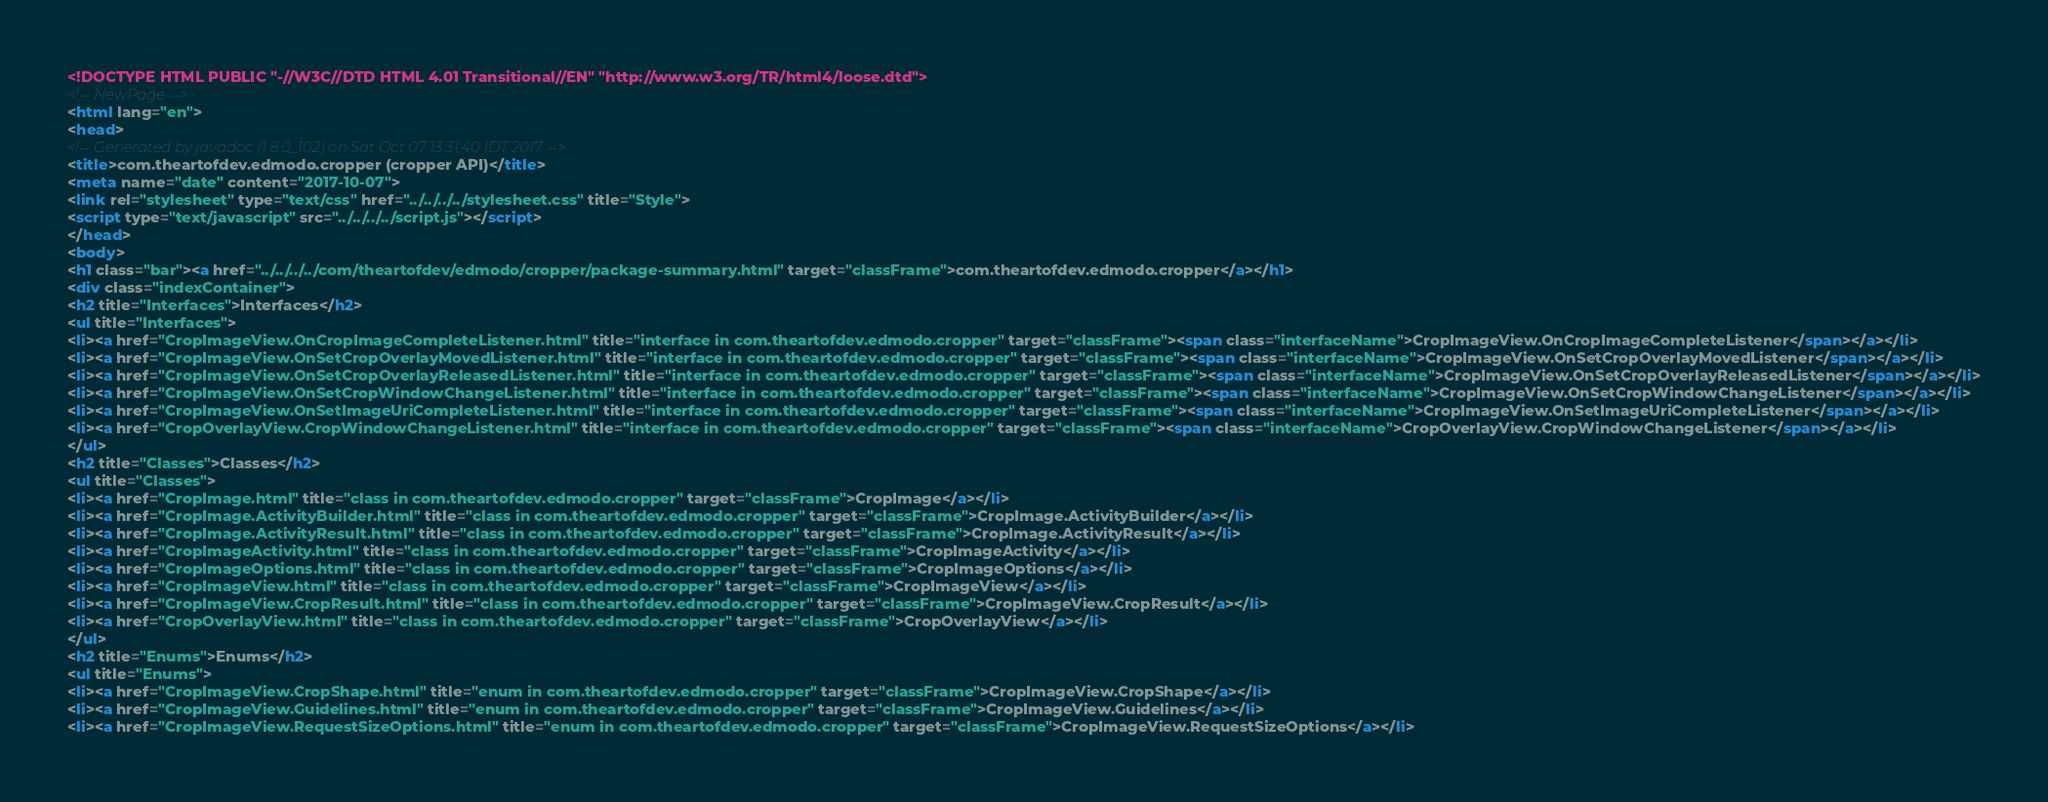<code> <loc_0><loc_0><loc_500><loc_500><_HTML_><!DOCTYPE HTML PUBLIC "-//W3C//DTD HTML 4.01 Transitional//EN" "http://www.w3.org/TR/html4/loose.dtd">
<!-- NewPage -->
<html lang="en">
<head>
<!-- Generated by javadoc (1.8.0_102) on Sat Oct 07 13:31:40 IDT 2017 -->
<title>com.theartofdev.edmodo.cropper (cropper API)</title>
<meta name="date" content="2017-10-07">
<link rel="stylesheet" type="text/css" href="../../../../stylesheet.css" title="Style">
<script type="text/javascript" src="../../../../script.js"></script>
</head>
<body>
<h1 class="bar"><a href="../../../../com/theartofdev/edmodo/cropper/package-summary.html" target="classFrame">com.theartofdev.edmodo.cropper</a></h1>
<div class="indexContainer">
<h2 title="Interfaces">Interfaces</h2>
<ul title="Interfaces">
<li><a href="CropImageView.OnCropImageCompleteListener.html" title="interface in com.theartofdev.edmodo.cropper" target="classFrame"><span class="interfaceName">CropImageView.OnCropImageCompleteListener</span></a></li>
<li><a href="CropImageView.OnSetCropOverlayMovedListener.html" title="interface in com.theartofdev.edmodo.cropper" target="classFrame"><span class="interfaceName">CropImageView.OnSetCropOverlayMovedListener</span></a></li>
<li><a href="CropImageView.OnSetCropOverlayReleasedListener.html" title="interface in com.theartofdev.edmodo.cropper" target="classFrame"><span class="interfaceName">CropImageView.OnSetCropOverlayReleasedListener</span></a></li>
<li><a href="CropImageView.OnSetCropWindowChangeListener.html" title="interface in com.theartofdev.edmodo.cropper" target="classFrame"><span class="interfaceName">CropImageView.OnSetCropWindowChangeListener</span></a></li>
<li><a href="CropImageView.OnSetImageUriCompleteListener.html" title="interface in com.theartofdev.edmodo.cropper" target="classFrame"><span class="interfaceName">CropImageView.OnSetImageUriCompleteListener</span></a></li>
<li><a href="CropOverlayView.CropWindowChangeListener.html" title="interface in com.theartofdev.edmodo.cropper" target="classFrame"><span class="interfaceName">CropOverlayView.CropWindowChangeListener</span></a></li>
</ul>
<h2 title="Classes">Classes</h2>
<ul title="Classes">
<li><a href="CropImage.html" title="class in com.theartofdev.edmodo.cropper" target="classFrame">CropImage</a></li>
<li><a href="CropImage.ActivityBuilder.html" title="class in com.theartofdev.edmodo.cropper" target="classFrame">CropImage.ActivityBuilder</a></li>
<li><a href="CropImage.ActivityResult.html" title="class in com.theartofdev.edmodo.cropper" target="classFrame">CropImage.ActivityResult</a></li>
<li><a href="CropImageActivity.html" title="class in com.theartofdev.edmodo.cropper" target="classFrame">CropImageActivity</a></li>
<li><a href="CropImageOptions.html" title="class in com.theartofdev.edmodo.cropper" target="classFrame">CropImageOptions</a></li>
<li><a href="CropImageView.html" title="class in com.theartofdev.edmodo.cropper" target="classFrame">CropImageView</a></li>
<li><a href="CropImageView.CropResult.html" title="class in com.theartofdev.edmodo.cropper" target="classFrame">CropImageView.CropResult</a></li>
<li><a href="CropOverlayView.html" title="class in com.theartofdev.edmodo.cropper" target="classFrame">CropOverlayView</a></li>
</ul>
<h2 title="Enums">Enums</h2>
<ul title="Enums">
<li><a href="CropImageView.CropShape.html" title="enum in com.theartofdev.edmodo.cropper" target="classFrame">CropImageView.CropShape</a></li>
<li><a href="CropImageView.Guidelines.html" title="enum in com.theartofdev.edmodo.cropper" target="classFrame">CropImageView.Guidelines</a></li>
<li><a href="CropImageView.RequestSizeOptions.html" title="enum in com.theartofdev.edmodo.cropper" target="classFrame">CropImageView.RequestSizeOptions</a></li></code> 